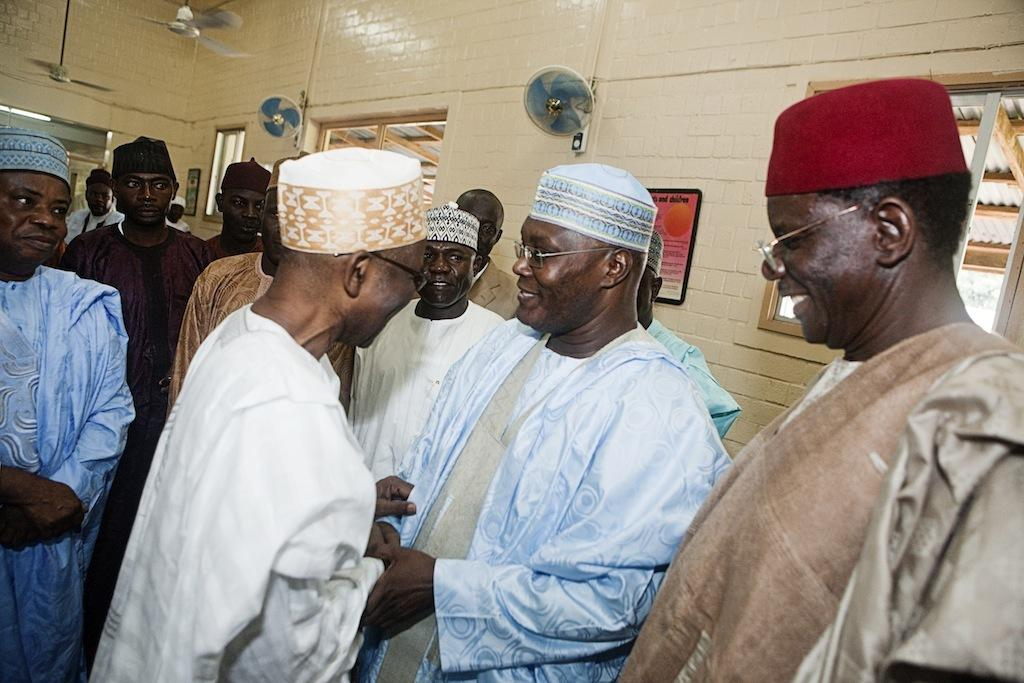What is the main subject of the image? The main subject of the image is a group of people. What can be seen on the right side of the image? There is a window on the right side of the image. What is present at the top of the image? There are fans visible at the top of the image. Can you tell me how many snakes are slithering on the floor in the image? There are no snakes present in the image; it features a group of people, a window, and fans. What type of muscle is being exercised by the people in the image? The image does not show any specific muscles being exercised; it simply depicts a group of people. 